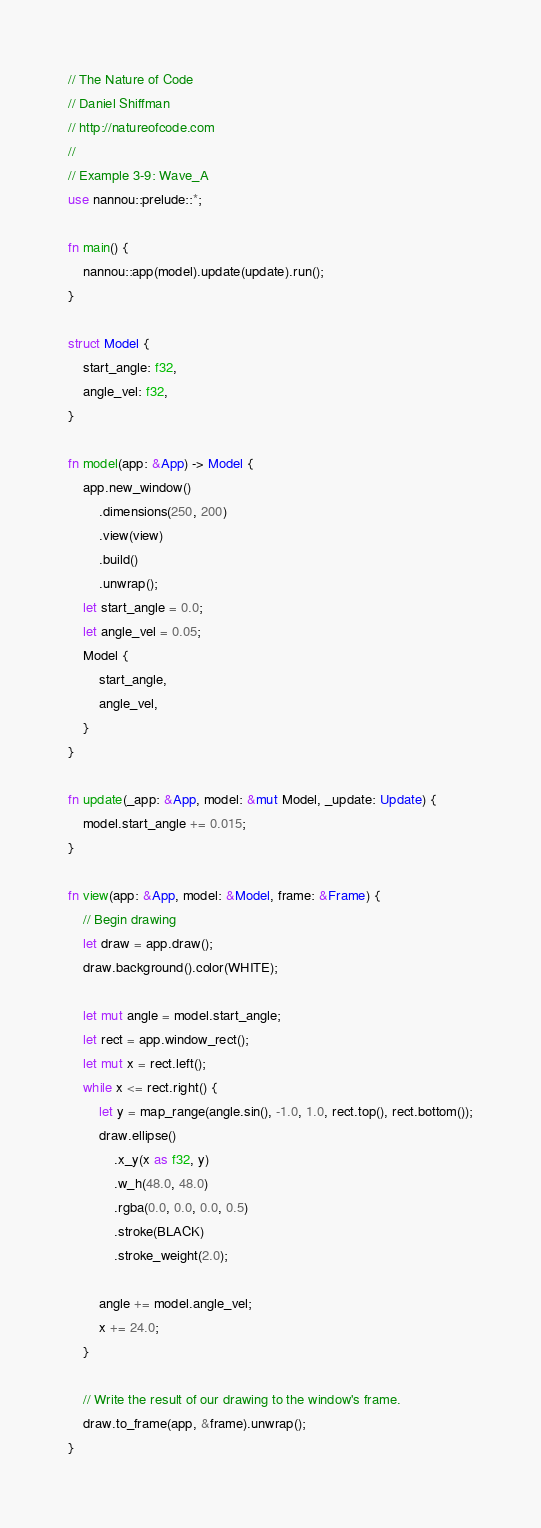<code> <loc_0><loc_0><loc_500><loc_500><_Rust_>// The Nature of Code
// Daniel Shiffman
// http://natureofcode.com
//
// Example 3-9: Wave_A
use nannou::prelude::*;

fn main() {
    nannou::app(model).update(update).run();
}

struct Model {
    start_angle: f32,
    angle_vel: f32,
}

fn model(app: &App) -> Model {
    app.new_window()
        .dimensions(250, 200)
        .view(view)
        .build()
        .unwrap();
    let start_angle = 0.0;
    let angle_vel = 0.05;
    Model {
        start_angle,
        angle_vel,
    }
}

fn update(_app: &App, model: &mut Model, _update: Update) {
    model.start_angle += 0.015;
}

fn view(app: &App, model: &Model, frame: &Frame) {
    // Begin drawing
    let draw = app.draw();
    draw.background().color(WHITE);

    let mut angle = model.start_angle;
    let rect = app.window_rect();
    let mut x = rect.left();
    while x <= rect.right() {
        let y = map_range(angle.sin(), -1.0, 1.0, rect.top(), rect.bottom());
        draw.ellipse()
            .x_y(x as f32, y)
            .w_h(48.0, 48.0)
            .rgba(0.0, 0.0, 0.0, 0.5)
            .stroke(BLACK)
            .stroke_weight(2.0);

        angle += model.angle_vel;
        x += 24.0;
    }

    // Write the result of our drawing to the window's frame.
    draw.to_frame(app, &frame).unwrap();
}
</code> 